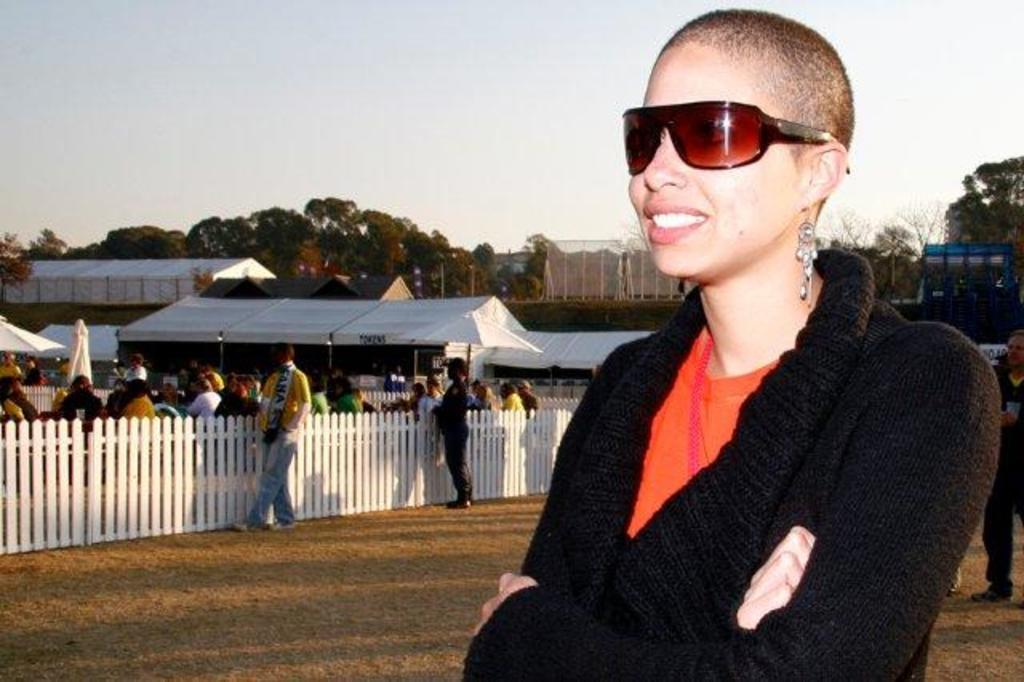What is the woman in the image doing? The woman is standing on the ground in the image. What can be seen in the background of the image? In the background of the image, there is fencing, sheds, people standing on the ground, trees, and the sky. How many elements can be identified in the background of the image? There are five elements in the background of the image: fencing, sheds, people, trees, and the sky. What type of quartz can be seen hanging from the fencing in the image? There is no quartz present in the image, and therefore no such object can be observed hanging from the fencing. 